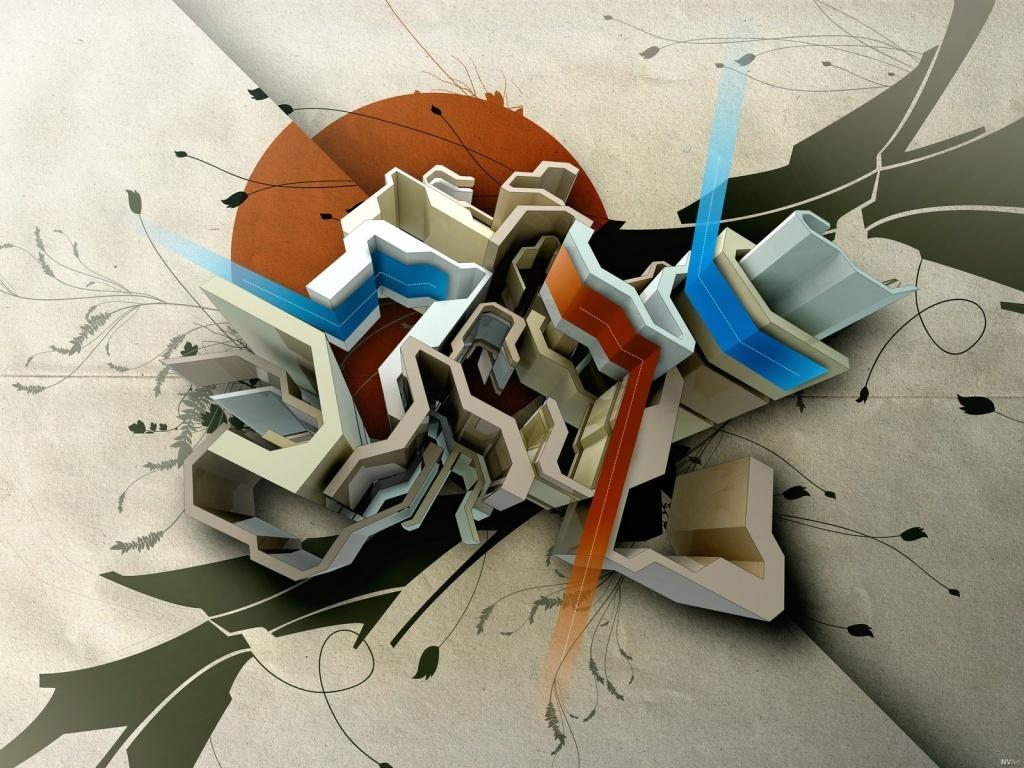What type of image is being described? The image is an animation. What can be seen in the center of the image? There are buildings in the center of the image. What is visible in the sky in the image? The sun is visible in the image. What type of design elements are present in the image? There are floral designs in the image. How much salt is sprinkled on the patch in the image? There is no salt or patch present in the image. What type of organization is depicted in the image? The image does not depict any organization; it features buildings, the sun, and floral designs. 